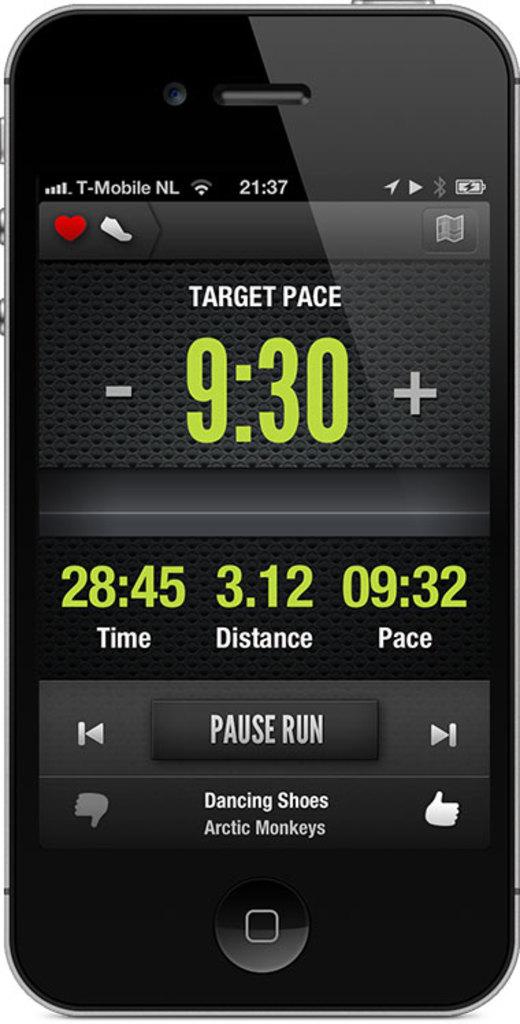What carrier is the phone from?
Offer a very short reply. T-mobile. What is the distance?
Offer a terse response. 3.12. 